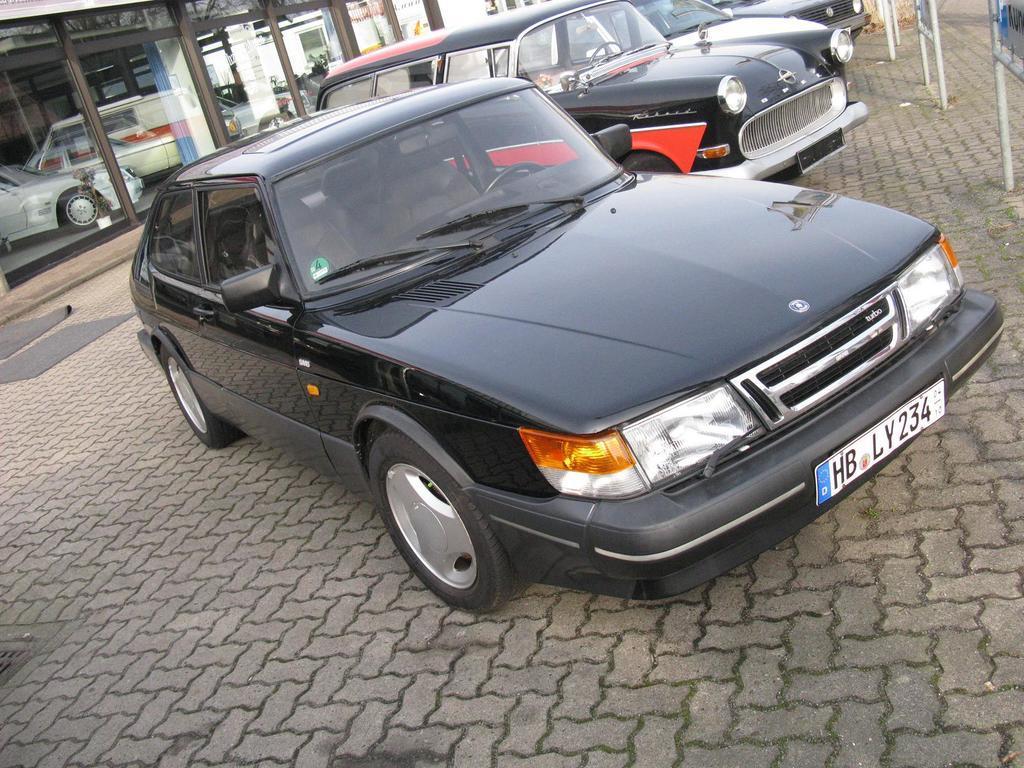Please provide a concise description of this image. In this image we can see the cars parked on the path. We can also see the mats and also the car showroom. On the right we can see the boards. 